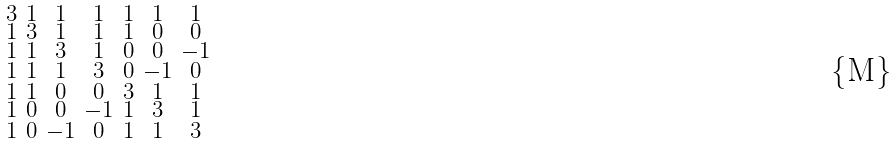Convert formula to latex. <formula><loc_0><loc_0><loc_500><loc_500>\begin{smallmatrix} 3 & 1 & 1 & 1 & 1 & 1 & 1 \\ 1 & 3 & 1 & 1 & 1 & 0 & 0 \\ 1 & 1 & 3 & 1 & 0 & 0 & - 1 \\ 1 & 1 & 1 & 3 & 0 & - 1 & 0 \\ 1 & 1 & 0 & 0 & 3 & 1 & 1 \\ 1 & 0 & 0 & - 1 & 1 & 3 & 1 \\ 1 & 0 & - 1 & 0 & 1 & 1 & 3 \end{smallmatrix}</formula> 